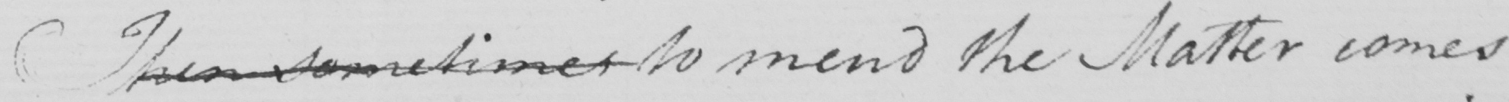What text is written in this handwritten line? Then sometimes to mend the Matter comes 